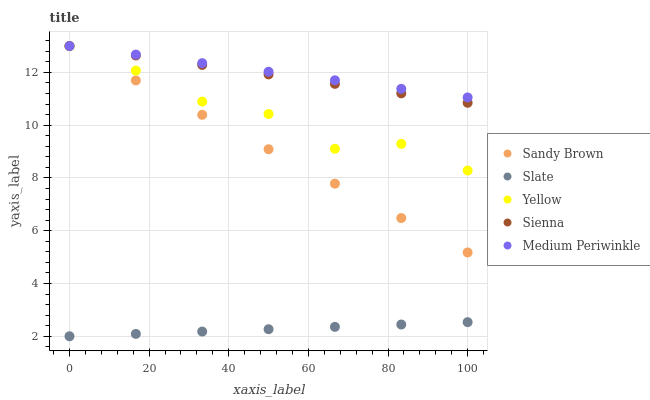Does Slate have the minimum area under the curve?
Answer yes or no. Yes. Does Medium Periwinkle have the maximum area under the curve?
Answer yes or no. Yes. Does Medium Periwinkle have the minimum area under the curve?
Answer yes or no. No. Does Slate have the maximum area under the curve?
Answer yes or no. No. Is Slate the smoothest?
Answer yes or no. Yes. Is Yellow the roughest?
Answer yes or no. Yes. Is Medium Periwinkle the smoothest?
Answer yes or no. No. Is Medium Periwinkle the roughest?
Answer yes or no. No. Does Slate have the lowest value?
Answer yes or no. Yes. Does Medium Periwinkle have the lowest value?
Answer yes or no. No. Does Yellow have the highest value?
Answer yes or no. Yes. Does Slate have the highest value?
Answer yes or no. No. Is Slate less than Sienna?
Answer yes or no. Yes. Is Yellow greater than Slate?
Answer yes or no. Yes. Does Yellow intersect Sandy Brown?
Answer yes or no. Yes. Is Yellow less than Sandy Brown?
Answer yes or no. No. Is Yellow greater than Sandy Brown?
Answer yes or no. No. Does Slate intersect Sienna?
Answer yes or no. No. 